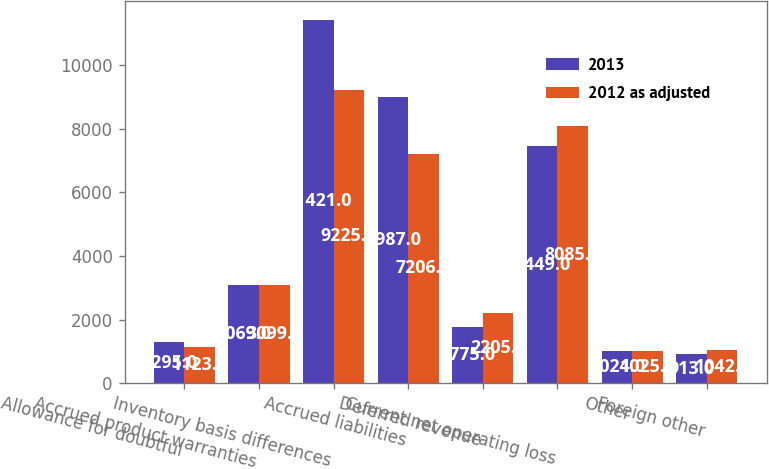Convert chart. <chart><loc_0><loc_0><loc_500><loc_500><stacked_bar_chart><ecel><fcel>Allowance for doubtful<fcel>Accrued product warranties<fcel>Inventory basis differences<fcel>Accrued liabilities<fcel>Deferred revenue<fcel>Current net operating loss<fcel>Other<fcel>Foreign other<nl><fcel>2013<fcel>1295<fcel>3069<fcel>11421<fcel>8987<fcel>1775<fcel>7449<fcel>1024<fcel>913<nl><fcel>2012 as adjusted<fcel>1123<fcel>3099<fcel>9225<fcel>7206<fcel>2205<fcel>8085<fcel>1025<fcel>1042<nl></chart> 